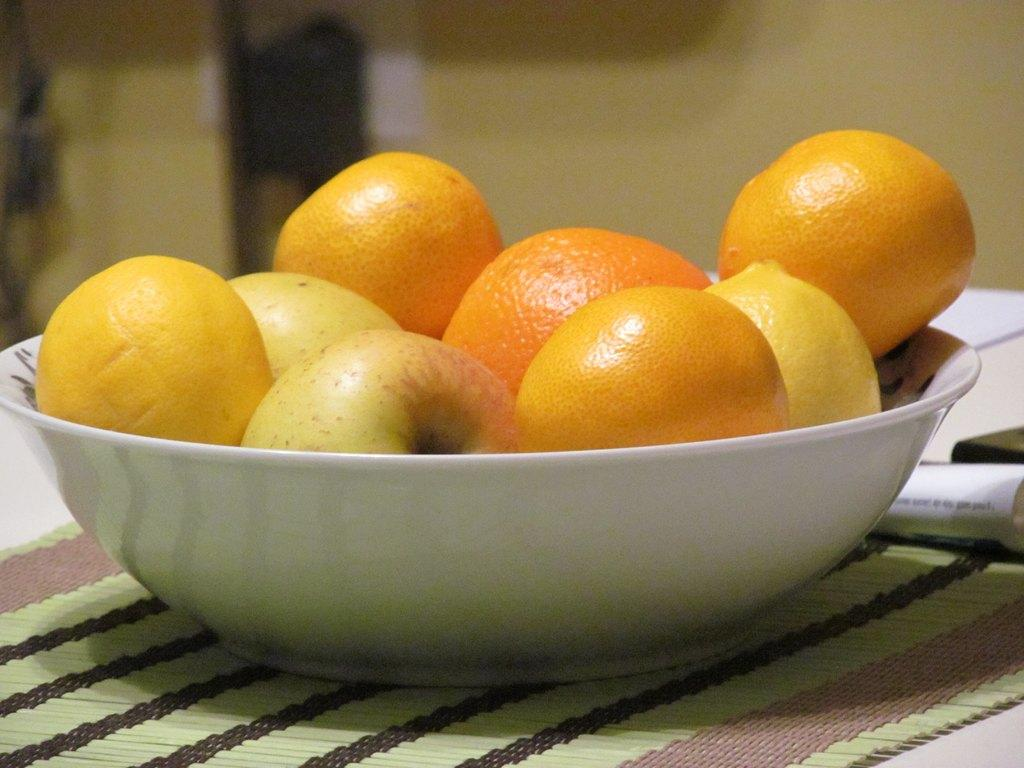What is in the bowl that is visible in the image? There are fruits in a bowl in the image. What else can be seen on the right side of the image? There is a paper on the right side of the image. Can you describe the background of the image? The background of the image is blurry. How does the honey help with the digestion of the fruits in the image? There is no honey present in the image, so it cannot be determined how it might affect the digestion of the fruits. 